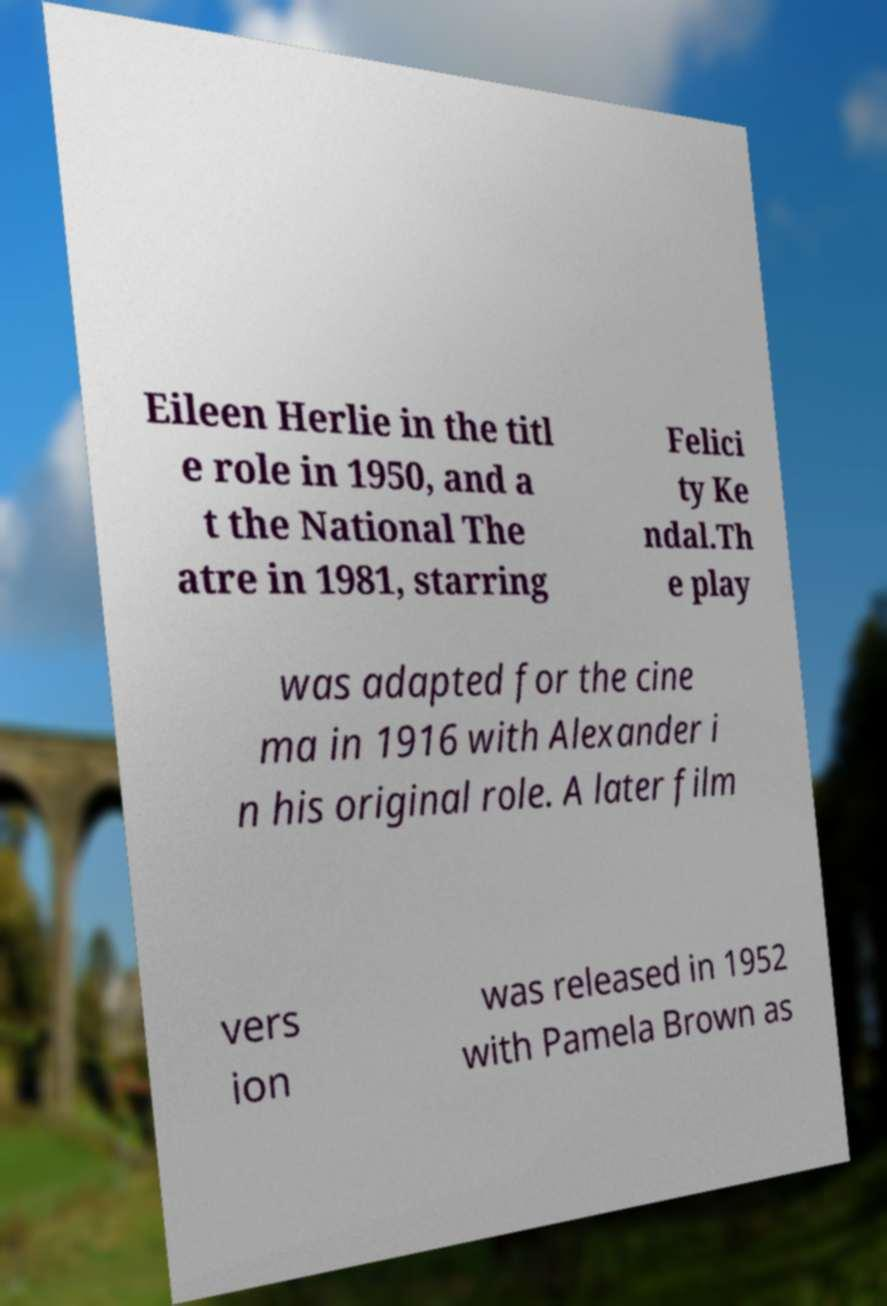What messages or text are displayed in this image? I need them in a readable, typed format. Eileen Herlie in the titl e role in 1950, and a t the National The atre in 1981, starring Felici ty Ke ndal.Th e play was adapted for the cine ma in 1916 with Alexander i n his original role. A later film vers ion was released in 1952 with Pamela Brown as 